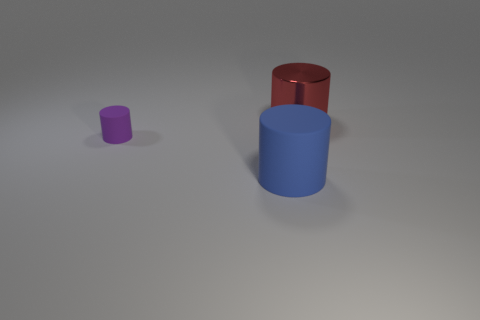How many other objects are there of the same material as the red object?
Provide a short and direct response. 0. What material is the other cylinder that is the same size as the shiny cylinder?
Your answer should be very brief. Rubber. There is a large cylinder on the left side of the red cylinder; does it have the same color as the big object right of the big blue thing?
Provide a short and direct response. No. Are there any other tiny brown metal objects that have the same shape as the metallic thing?
Your answer should be compact. No. What shape is the object that is the same size as the red cylinder?
Offer a terse response. Cylinder. How many other metal cylinders are the same color as the shiny cylinder?
Ensure brevity in your answer.  0. There is a matte cylinder that is to the left of the large matte cylinder; what size is it?
Your answer should be compact. Small. How many red shiny cylinders have the same size as the blue cylinder?
Give a very brief answer. 1. The other large object that is the same material as the purple object is what color?
Ensure brevity in your answer.  Blue. Is the number of tiny purple cylinders in front of the big blue thing less than the number of tiny blue metallic objects?
Keep it short and to the point. No. 